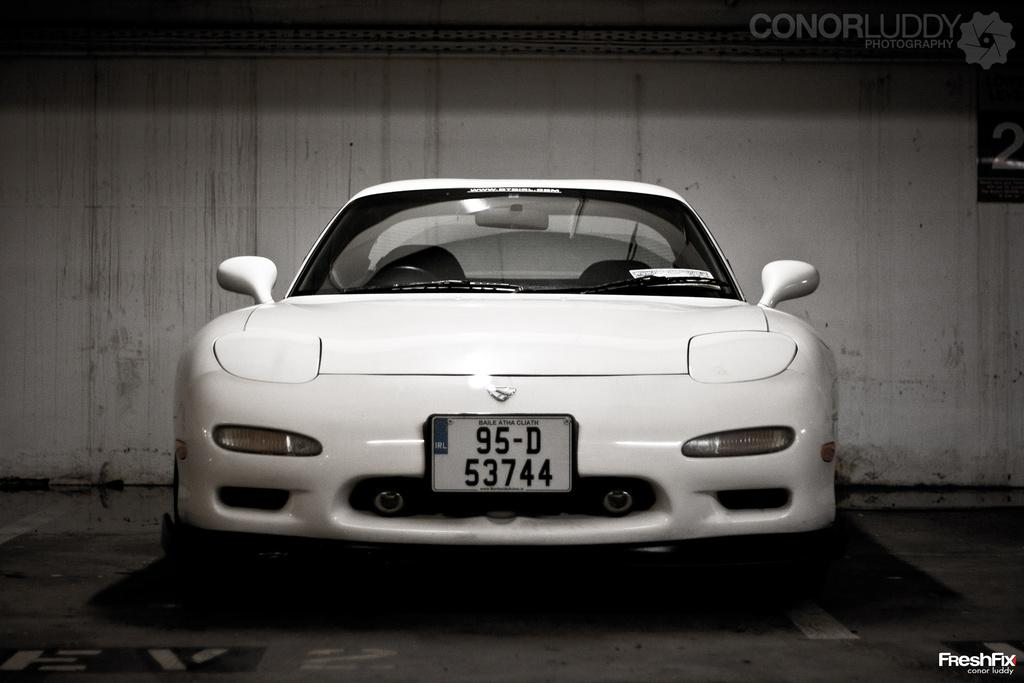What is the main subject in the image? There is a vehicle in the image. Where is the vehicle located? The vehicle is on the floor. What is behind the vehicle in the image? There is a wall behind the vehicle. Can you describe any additional features of the image? There is a watermark on the image. What type of corn is being harvested by the carpenter in the image? There is no corn or carpenter present in the image. Can you see any twigs being used as tools by the vehicle in the image? There are no twigs being used as tools in the image; the vehicle is stationary on the floor. 